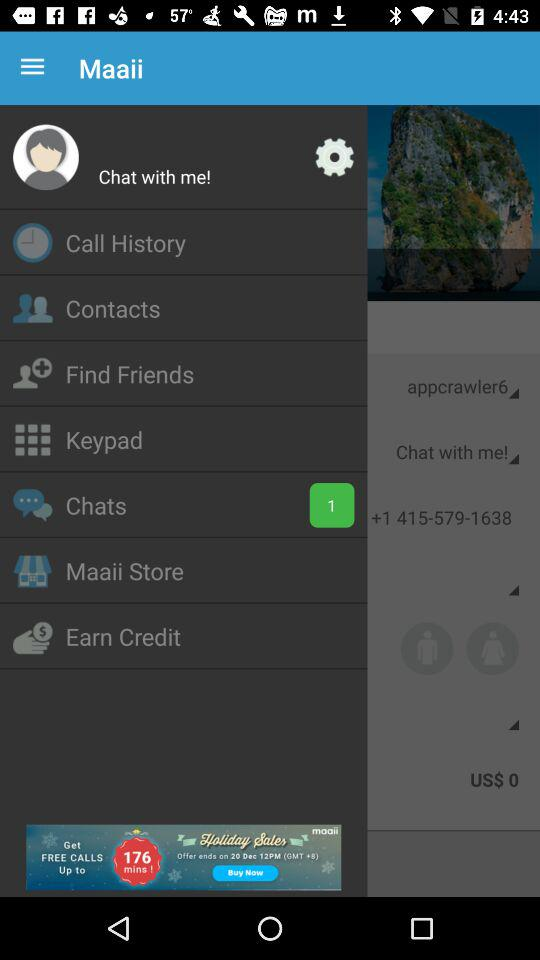How many unread chats are available? There is 1 unread chat. 